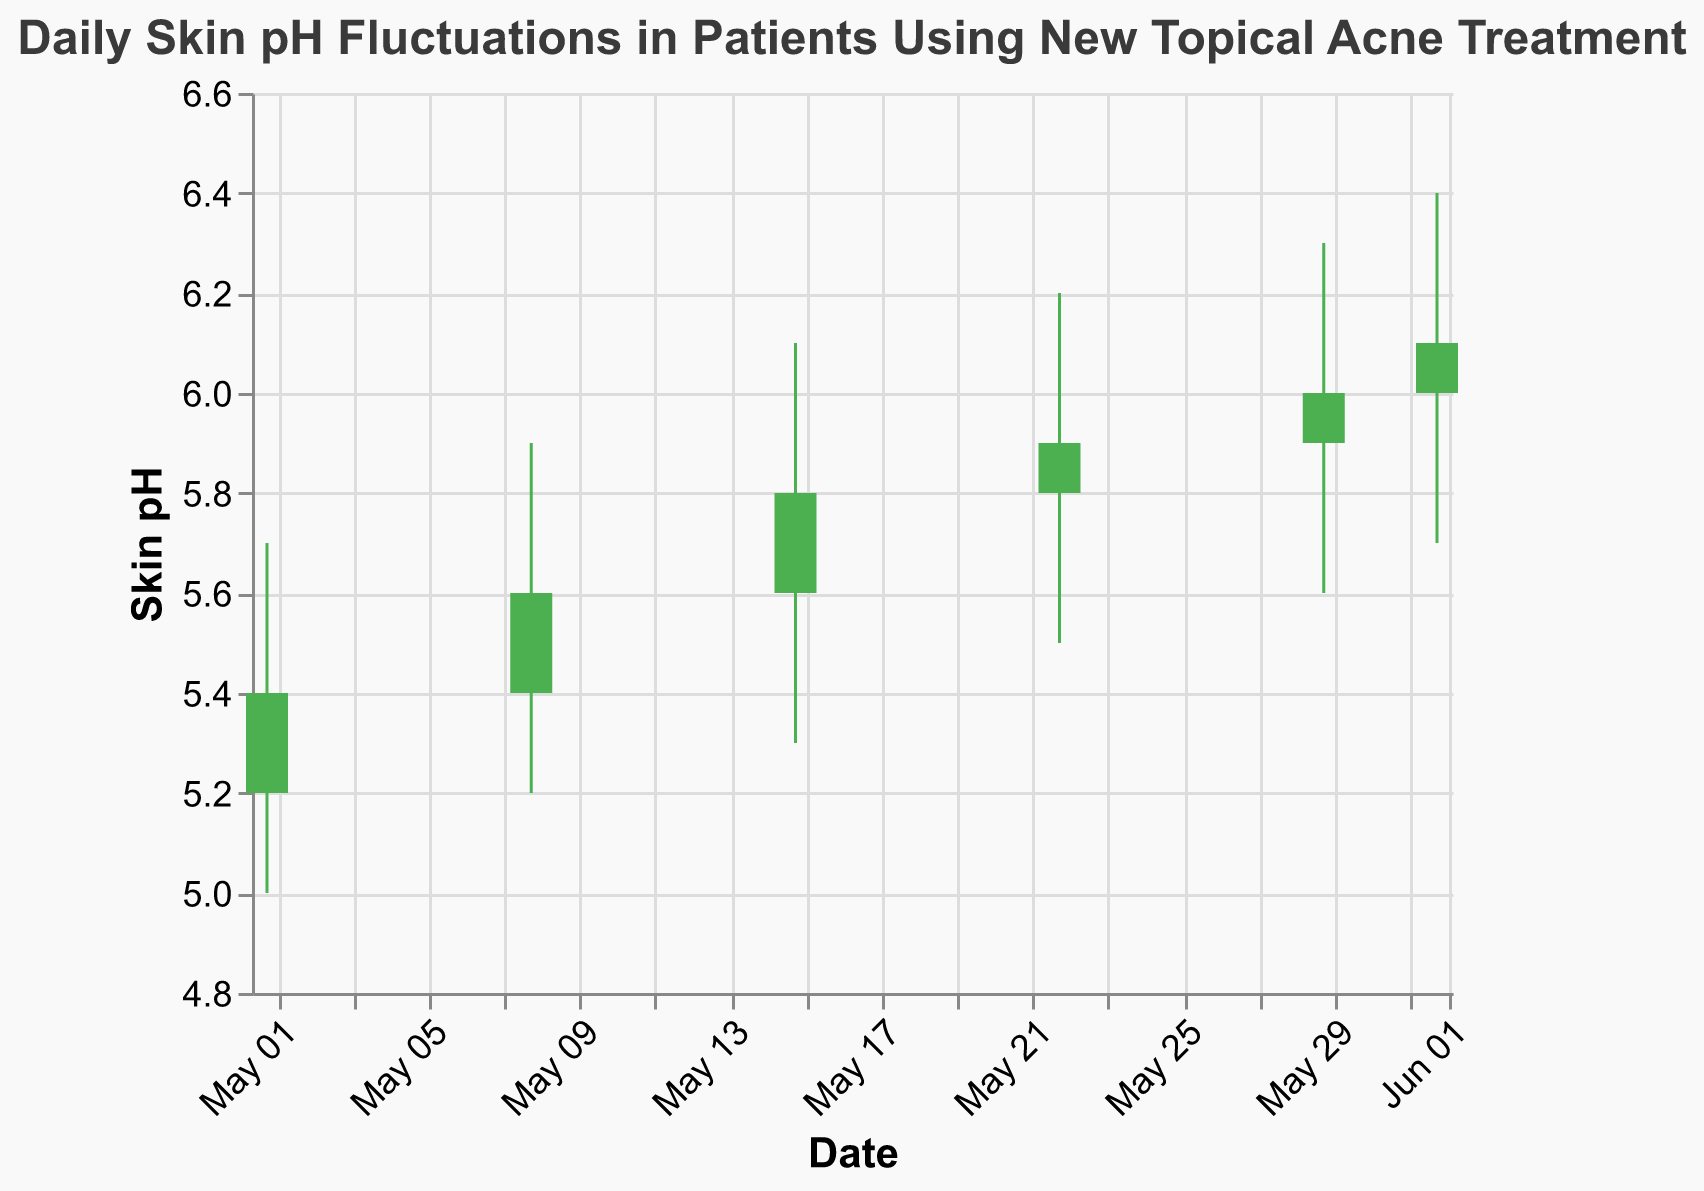What is the title of the chart? The title of the chart is written at the top center of the figure.
Answer: Daily Skin pH Fluctuations in Patients Using New Topical Acne Treatment How many data points are represented in the chart? Count the number of vertical bars or data points on the x-axis.
Answer: 6 What was the highest skin pH recorded, and on what date did it occur? Look at the 'High' values and find the maximum among them, then check the corresponding date.
Answer: 6.4 on 2023-06-01 What is the range (difference between the highest and lowest pH) for the week of May 22? Identify the 'High' and 'Low' values for the date 2023-05-22 and calculate their difference.
Answer: 0.7 (6.2 - 5.5) By how much did the skin pH increase from the open to the close on June 1? Find the 'Open' and 'Close' values for the date 2023-06-01 and calculate the difference.
Answer: 0.1 (6.1 - 6.0) Which week shows the highest increase in skin pH from open to close? Check the difference between the 'Close' and 'Open' for each date and find the maximum.
Answer: Week of May 29 How does the skin pH trend over the month? Observe the 'Close' values over the dates and determine if they show an increasing, decreasing, or fluctuating trend.
Answer: Increasing trend Compare the pH range of the first and last data points. Which has a larger range? Calculate the range (High - Low) for the dates 2023-05-01 and 2023-06-01, then compare.
Answer: First data point has a larger range (0.7 vs. 0.5) Are there any weeks where the 'Open' value is higher than the 'Close' value? Compare the 'Open' and 'Close' values for each week and identify if any 'Open' value is greater than the 'Close' value.
Answer: No On which date does the lowest skin pH value occur, and what is it? Look for the minimum 'Low' value and the corresponding date.
Answer: 5.0 on 2023-05-01 